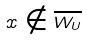Convert formula to latex. <formula><loc_0><loc_0><loc_500><loc_500>x \notin \overline { W _ { U } }</formula> 